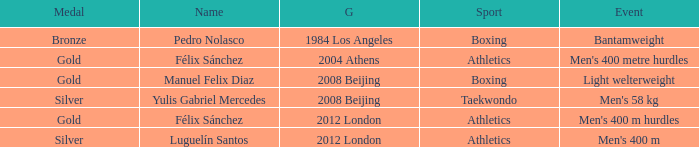Which Medal had a Games of 2008 beijing, and a Sport of taekwondo? Silver. 